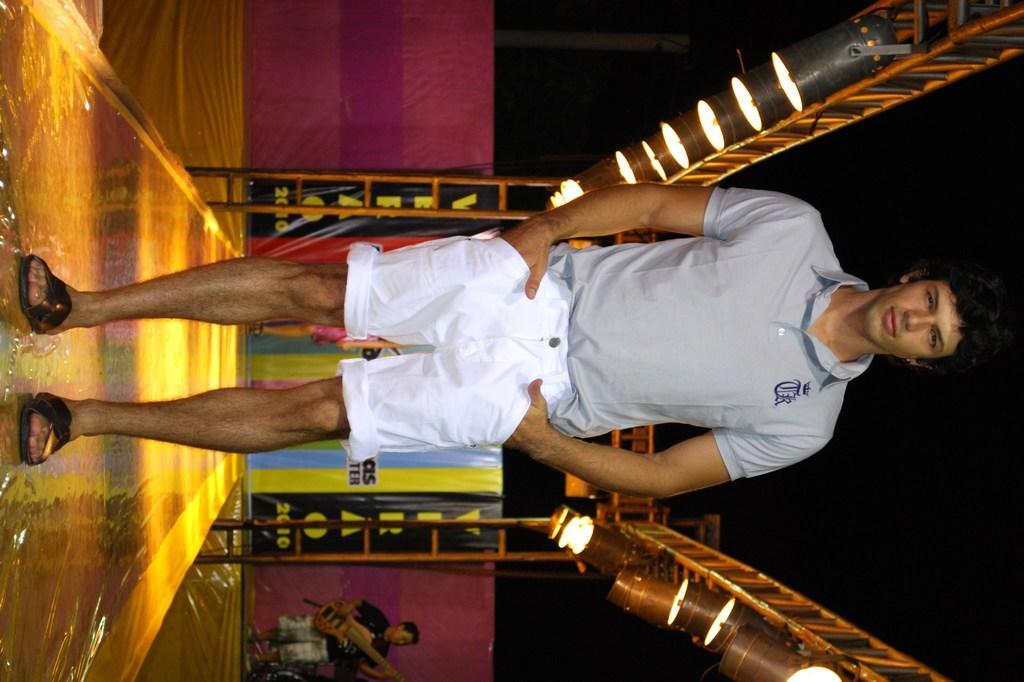Please provide a concise description of this image. In this image we can see a man standing, lights, metal frame and in the background, we can see a person holding an object. 